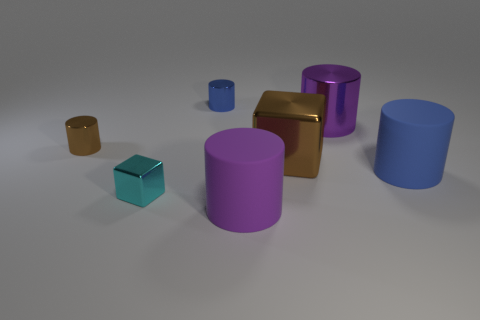Subtract all large purple metal cylinders. How many cylinders are left? 4 Add 3 small cyan metal cubes. How many objects exist? 10 Subtract all cyan blocks. How many blocks are left? 1 Subtract 1 cubes. How many cubes are left? 1 Subtract all blue cylinders. Subtract all purple spheres. How many cylinders are left? 3 Subtract all blue cylinders. How many cyan blocks are left? 1 Subtract all tiny blue shiny cylinders. Subtract all big metallic blocks. How many objects are left? 5 Add 6 shiny cylinders. How many shiny cylinders are left? 9 Add 2 tiny blue metallic things. How many tiny blue metallic things exist? 3 Subtract 0 yellow spheres. How many objects are left? 7 